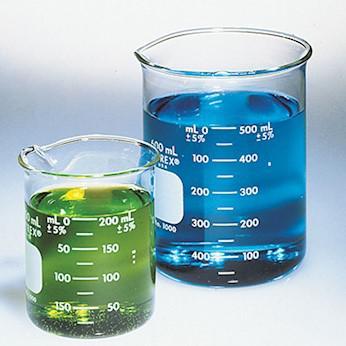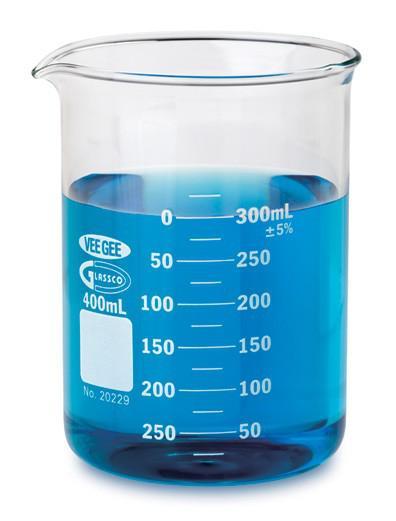The first image is the image on the left, the second image is the image on the right. For the images shown, is this caption "There is no less than one clear beaker filled with a blue liquid" true? Answer yes or no. Yes. The first image is the image on the left, the second image is the image on the right. For the images shown, is this caption "blu liquid is in the beaker" true? Answer yes or no. Yes. 